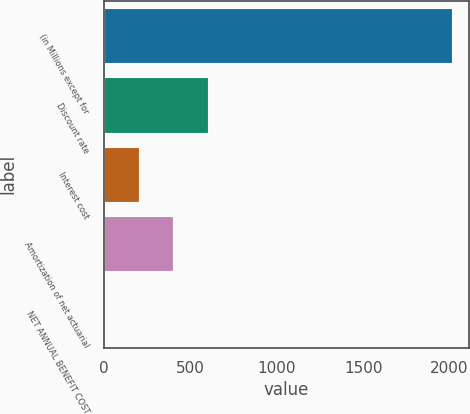Convert chart. <chart><loc_0><loc_0><loc_500><loc_500><bar_chart><fcel>(in Millions except for<fcel>Discount rate<fcel>Interest cost<fcel>Amortization of net actuarial<fcel>NET ANNUAL BENEFIT COST<nl><fcel>2014<fcel>604.41<fcel>201.67<fcel>403.04<fcel>0.3<nl></chart> 